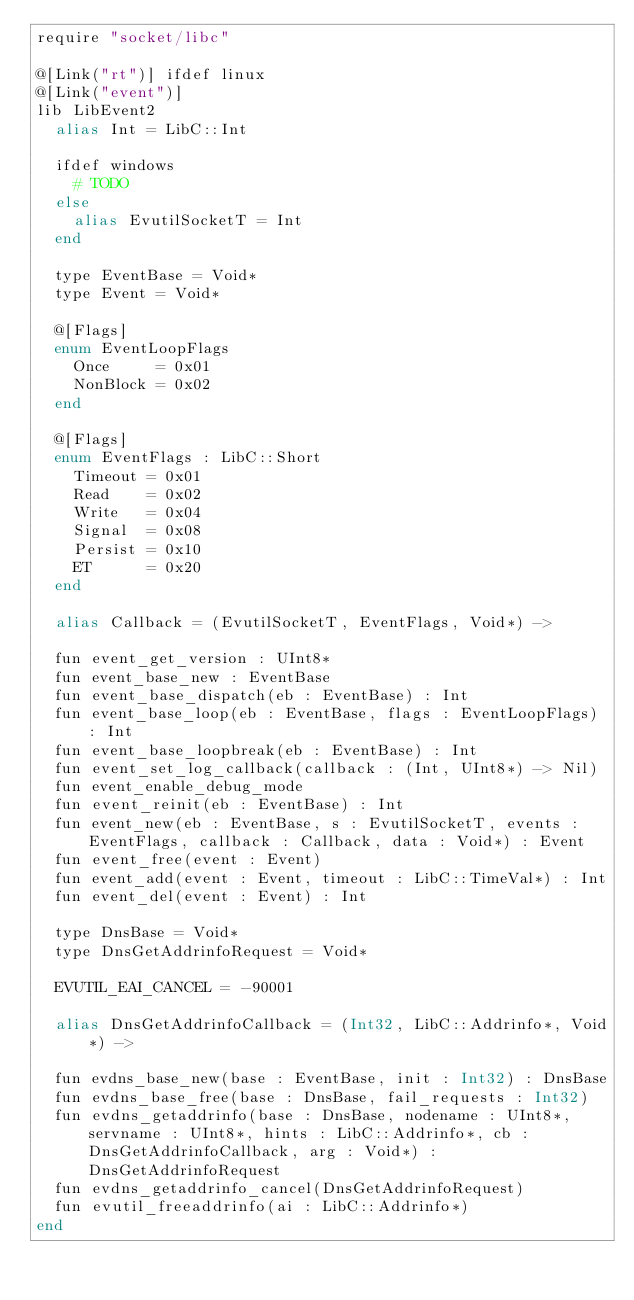<code> <loc_0><loc_0><loc_500><loc_500><_Crystal_>require "socket/libc"

@[Link("rt")] ifdef linux
@[Link("event")]
lib LibEvent2
  alias Int = LibC::Int

  ifdef windows
    # TODO
  else
    alias EvutilSocketT = Int
  end

  type EventBase = Void*
  type Event = Void*

  @[Flags]
  enum EventLoopFlags
    Once     = 0x01
    NonBlock = 0x02
  end

  @[Flags]
  enum EventFlags : LibC::Short
    Timeout = 0x01
    Read    = 0x02
    Write   = 0x04
    Signal  = 0x08
    Persist = 0x10
    ET      = 0x20
  end

  alias Callback = (EvutilSocketT, EventFlags, Void*) ->

  fun event_get_version : UInt8*
  fun event_base_new : EventBase
  fun event_base_dispatch(eb : EventBase) : Int
  fun event_base_loop(eb : EventBase, flags : EventLoopFlags) : Int
  fun event_base_loopbreak(eb : EventBase) : Int
  fun event_set_log_callback(callback : (Int, UInt8*) -> Nil)
  fun event_enable_debug_mode
  fun event_reinit(eb : EventBase) : Int
  fun event_new(eb : EventBase, s : EvutilSocketT, events : EventFlags, callback : Callback, data : Void*) : Event
  fun event_free(event : Event)
  fun event_add(event : Event, timeout : LibC::TimeVal*) : Int
  fun event_del(event : Event) : Int

  type DnsBase = Void*
  type DnsGetAddrinfoRequest = Void*

  EVUTIL_EAI_CANCEL = -90001

  alias DnsGetAddrinfoCallback = (Int32, LibC::Addrinfo*, Void*) ->

  fun evdns_base_new(base : EventBase, init : Int32) : DnsBase
  fun evdns_base_free(base : DnsBase, fail_requests : Int32)
  fun evdns_getaddrinfo(base : DnsBase, nodename : UInt8*, servname : UInt8*, hints : LibC::Addrinfo*, cb : DnsGetAddrinfoCallback, arg : Void*) : DnsGetAddrinfoRequest
  fun evdns_getaddrinfo_cancel(DnsGetAddrinfoRequest)
  fun evutil_freeaddrinfo(ai : LibC::Addrinfo*)
end
</code> 